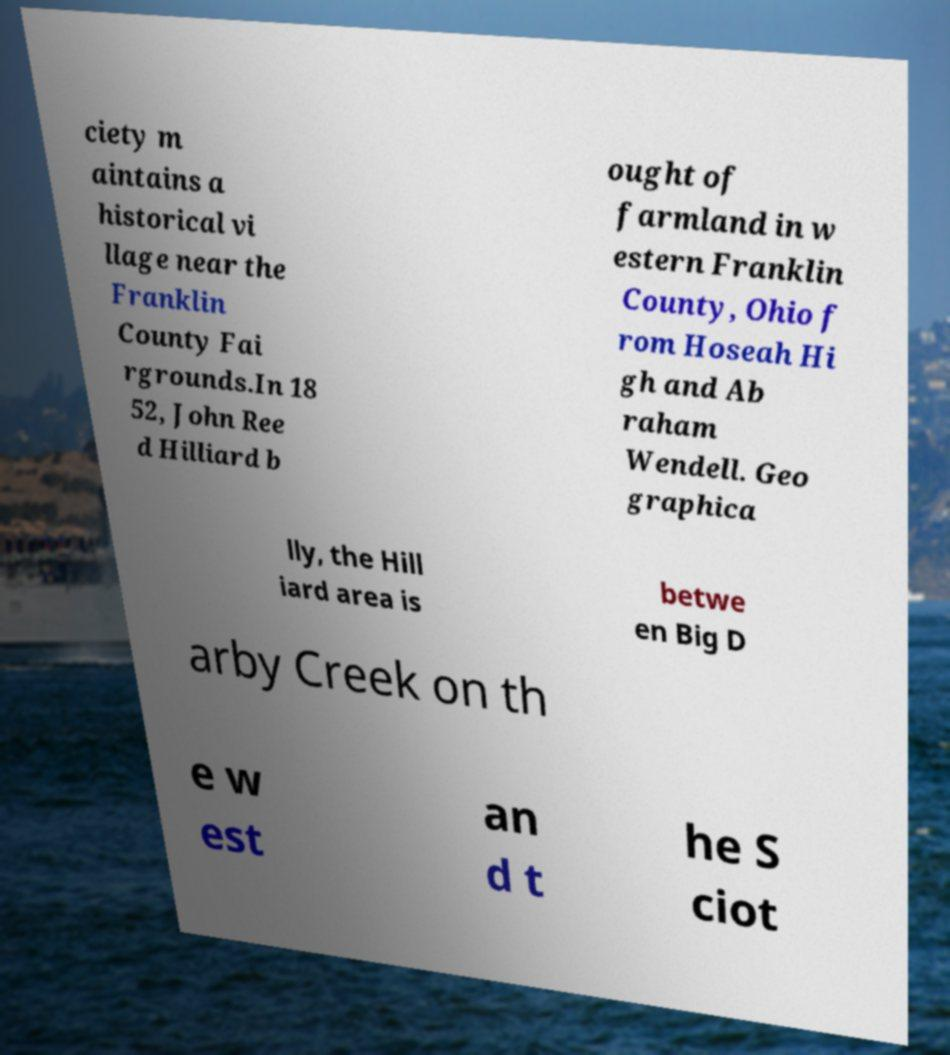Could you extract and type out the text from this image? ciety m aintains a historical vi llage near the Franklin County Fai rgrounds.In 18 52, John Ree d Hilliard b ought of farmland in w estern Franklin County, Ohio f rom Hoseah Hi gh and Ab raham Wendell. Geo graphica lly, the Hill iard area is betwe en Big D arby Creek on th e w est an d t he S ciot 